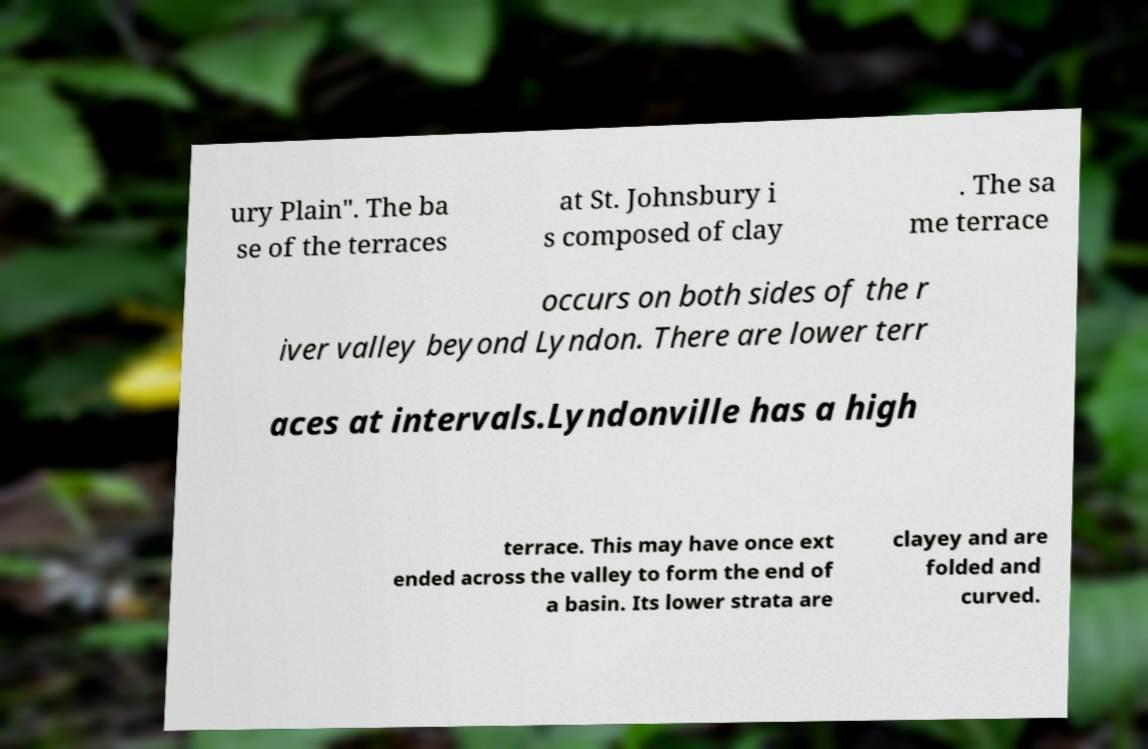What messages or text are displayed in this image? I need them in a readable, typed format. ury Plain". The ba se of the terraces at St. Johnsbury i s composed of clay . The sa me terrace occurs on both sides of the r iver valley beyond Lyndon. There are lower terr aces at intervals.Lyndonville has a high terrace. This may have once ext ended across the valley to form the end of a basin. Its lower strata are clayey and are folded and curved. 